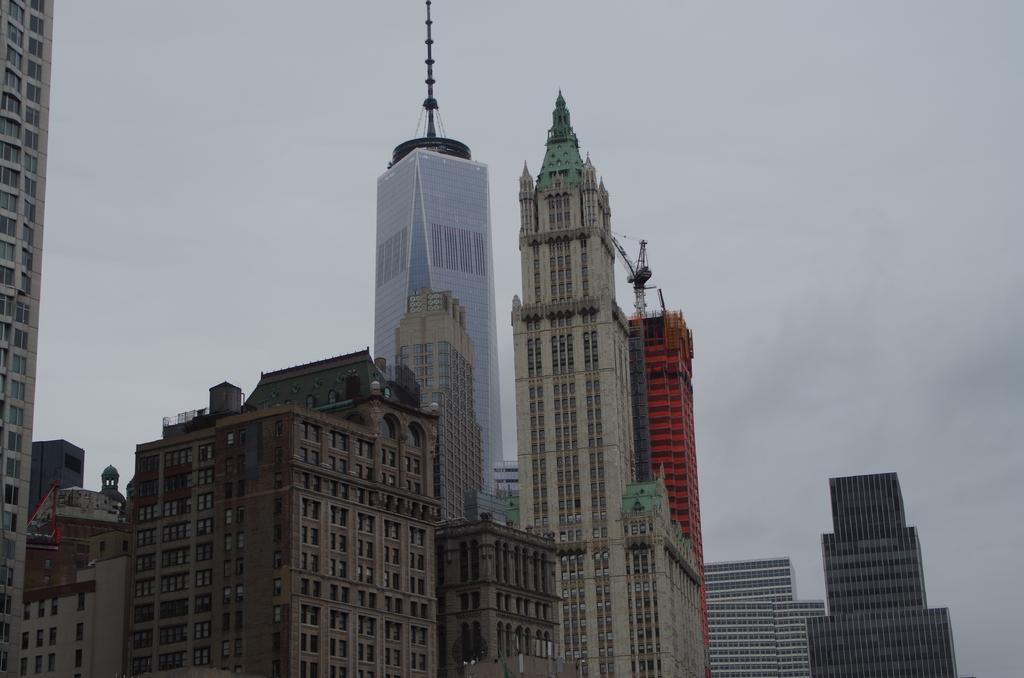What structures are present in the image? There are buildings in the image. What part of the natural environment is visible in the image? The sky is visible in the image. Is there any quiver visible in the image? There is no quiver present in the image. Can you see any quicksand in the image? There is no quicksand present in the image. 